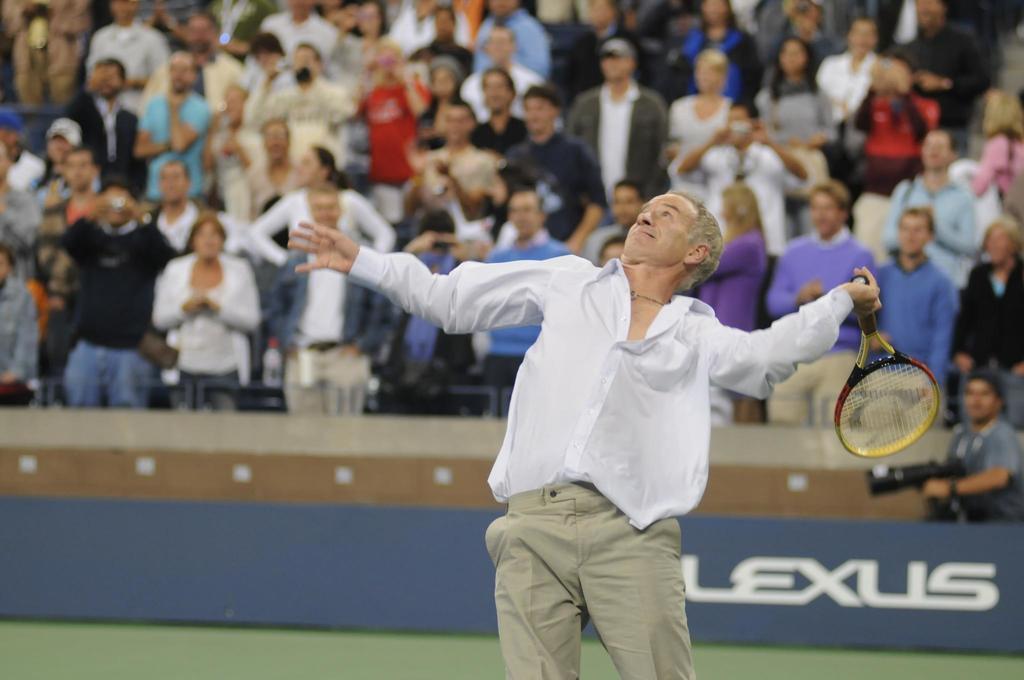Can you describe this image briefly? In this image I can see a man with a racket in his hand. In the background I can see number of people. 